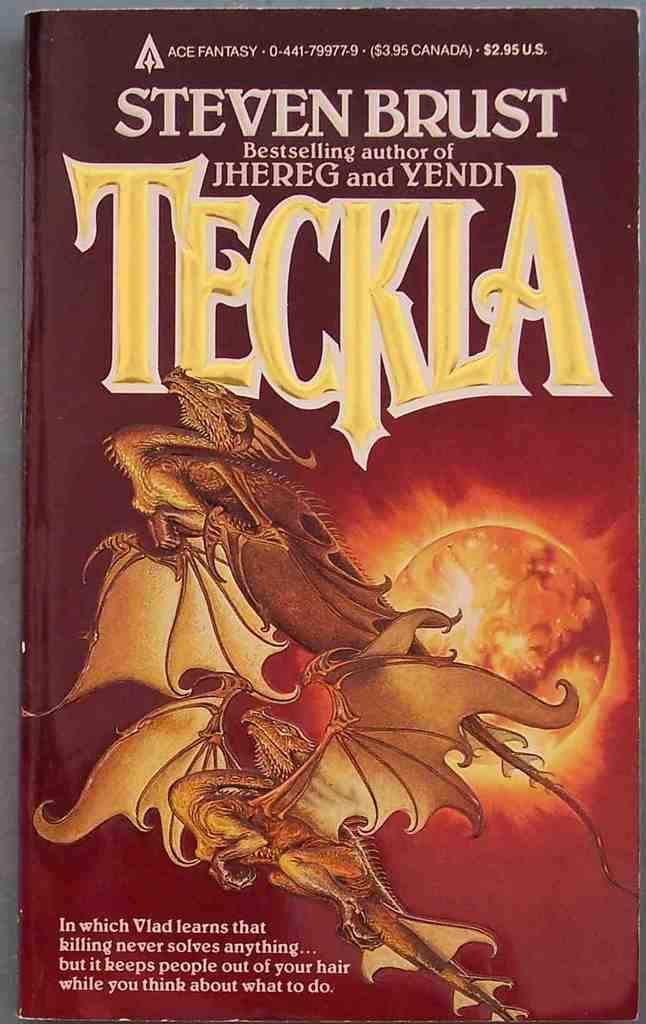<image>
Render a clear and concise summary of the photo. A book by Steven Brust has dragons on the front cover. 